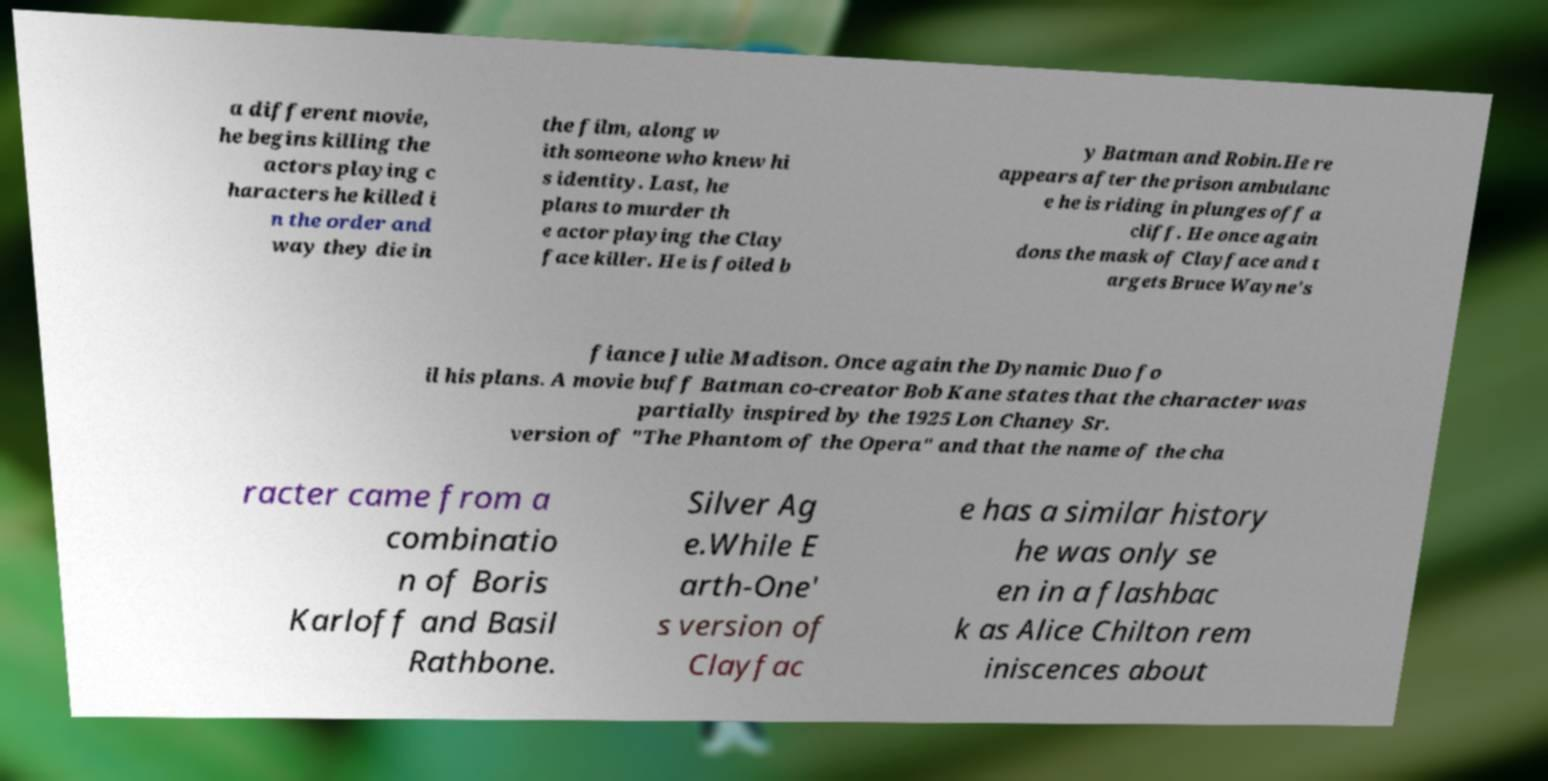For documentation purposes, I need the text within this image transcribed. Could you provide that? a different movie, he begins killing the actors playing c haracters he killed i n the order and way they die in the film, along w ith someone who knew hi s identity. Last, he plans to murder th e actor playing the Clay face killer. He is foiled b y Batman and Robin.He re appears after the prison ambulanc e he is riding in plunges off a cliff. He once again dons the mask of Clayface and t argets Bruce Wayne's fiance Julie Madison. Once again the Dynamic Duo fo il his plans. A movie buff Batman co-creator Bob Kane states that the character was partially inspired by the 1925 Lon Chaney Sr. version of "The Phantom of the Opera" and that the name of the cha racter came from a combinatio n of Boris Karloff and Basil Rathbone. Silver Ag e.While E arth-One' s version of Clayfac e has a similar history he was only se en in a flashbac k as Alice Chilton rem iniscences about 